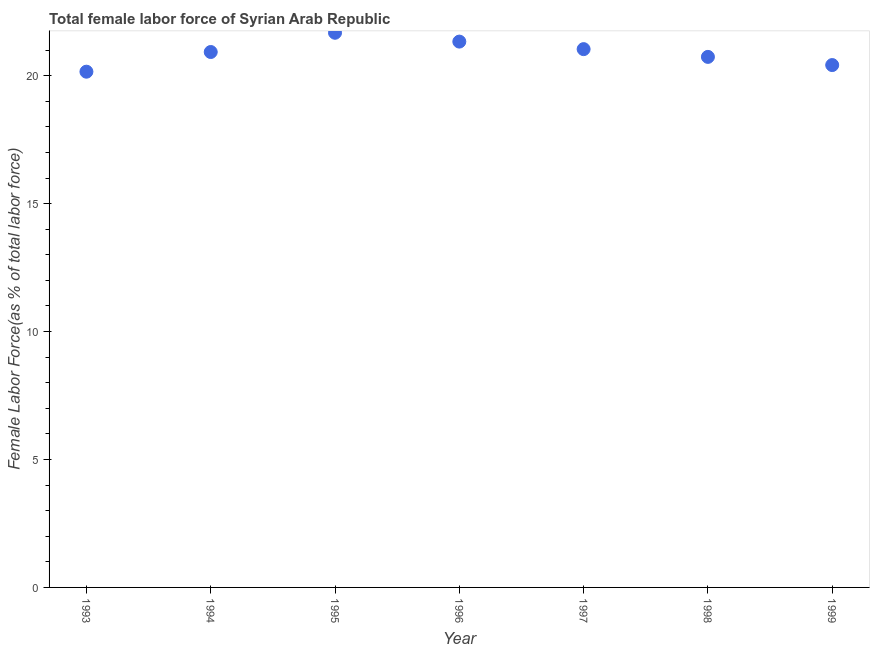What is the total female labor force in 1997?
Make the answer very short. 21.04. Across all years, what is the maximum total female labor force?
Ensure brevity in your answer.  21.68. Across all years, what is the minimum total female labor force?
Your answer should be compact. 20.16. In which year was the total female labor force maximum?
Provide a short and direct response. 1995. In which year was the total female labor force minimum?
Provide a short and direct response. 1993. What is the sum of the total female labor force?
Provide a short and direct response. 146.29. What is the difference between the total female labor force in 1998 and 1999?
Offer a terse response. 0.32. What is the average total female labor force per year?
Provide a succinct answer. 20.9. What is the median total female labor force?
Give a very brief answer. 20.93. What is the ratio of the total female labor force in 1993 to that in 1996?
Provide a short and direct response. 0.94. Is the total female labor force in 1998 less than that in 1999?
Your response must be concise. No. Is the difference between the total female labor force in 1993 and 1994 greater than the difference between any two years?
Provide a succinct answer. No. What is the difference between the highest and the second highest total female labor force?
Ensure brevity in your answer.  0.35. Is the sum of the total female labor force in 1993 and 1995 greater than the maximum total female labor force across all years?
Provide a short and direct response. Yes. What is the difference between the highest and the lowest total female labor force?
Keep it short and to the point. 1.52. In how many years, is the total female labor force greater than the average total female labor force taken over all years?
Your response must be concise. 4. What is the difference between two consecutive major ticks on the Y-axis?
Offer a terse response. 5. Are the values on the major ticks of Y-axis written in scientific E-notation?
Ensure brevity in your answer.  No. Does the graph contain any zero values?
Your response must be concise. No. Does the graph contain grids?
Make the answer very short. No. What is the title of the graph?
Your response must be concise. Total female labor force of Syrian Arab Republic. What is the label or title of the X-axis?
Keep it short and to the point. Year. What is the label or title of the Y-axis?
Offer a very short reply. Female Labor Force(as % of total labor force). What is the Female Labor Force(as % of total labor force) in 1993?
Offer a terse response. 20.16. What is the Female Labor Force(as % of total labor force) in 1994?
Keep it short and to the point. 20.93. What is the Female Labor Force(as % of total labor force) in 1995?
Ensure brevity in your answer.  21.68. What is the Female Labor Force(as % of total labor force) in 1996?
Make the answer very short. 21.33. What is the Female Labor Force(as % of total labor force) in 1997?
Provide a succinct answer. 21.04. What is the Female Labor Force(as % of total labor force) in 1998?
Provide a succinct answer. 20.74. What is the Female Labor Force(as % of total labor force) in 1999?
Your response must be concise. 20.42. What is the difference between the Female Labor Force(as % of total labor force) in 1993 and 1994?
Give a very brief answer. -0.77. What is the difference between the Female Labor Force(as % of total labor force) in 1993 and 1995?
Offer a terse response. -1.52. What is the difference between the Female Labor Force(as % of total labor force) in 1993 and 1996?
Offer a very short reply. -1.18. What is the difference between the Female Labor Force(as % of total labor force) in 1993 and 1997?
Your answer should be compact. -0.88. What is the difference between the Female Labor Force(as % of total labor force) in 1993 and 1998?
Give a very brief answer. -0.58. What is the difference between the Female Labor Force(as % of total labor force) in 1993 and 1999?
Provide a succinct answer. -0.26. What is the difference between the Female Labor Force(as % of total labor force) in 1994 and 1995?
Your answer should be compact. -0.75. What is the difference between the Female Labor Force(as % of total labor force) in 1994 and 1996?
Provide a short and direct response. -0.41. What is the difference between the Female Labor Force(as % of total labor force) in 1994 and 1997?
Your response must be concise. -0.11. What is the difference between the Female Labor Force(as % of total labor force) in 1994 and 1998?
Keep it short and to the point. 0.19. What is the difference between the Female Labor Force(as % of total labor force) in 1994 and 1999?
Your answer should be compact. 0.51. What is the difference between the Female Labor Force(as % of total labor force) in 1995 and 1996?
Offer a terse response. 0.35. What is the difference between the Female Labor Force(as % of total labor force) in 1995 and 1997?
Give a very brief answer. 0.64. What is the difference between the Female Labor Force(as % of total labor force) in 1995 and 1998?
Offer a very short reply. 0.94. What is the difference between the Female Labor Force(as % of total labor force) in 1995 and 1999?
Make the answer very short. 1.26. What is the difference between the Female Labor Force(as % of total labor force) in 1996 and 1997?
Your answer should be compact. 0.29. What is the difference between the Female Labor Force(as % of total labor force) in 1996 and 1998?
Your response must be concise. 0.6. What is the difference between the Female Labor Force(as % of total labor force) in 1996 and 1999?
Provide a short and direct response. 0.92. What is the difference between the Female Labor Force(as % of total labor force) in 1997 and 1998?
Offer a terse response. 0.3. What is the difference between the Female Labor Force(as % of total labor force) in 1997 and 1999?
Offer a very short reply. 0.62. What is the difference between the Female Labor Force(as % of total labor force) in 1998 and 1999?
Offer a very short reply. 0.32. What is the ratio of the Female Labor Force(as % of total labor force) in 1993 to that in 1994?
Ensure brevity in your answer.  0.96. What is the ratio of the Female Labor Force(as % of total labor force) in 1993 to that in 1996?
Your answer should be compact. 0.94. What is the ratio of the Female Labor Force(as % of total labor force) in 1993 to that in 1997?
Your response must be concise. 0.96. What is the ratio of the Female Labor Force(as % of total labor force) in 1993 to that in 1998?
Offer a very short reply. 0.97. What is the ratio of the Female Labor Force(as % of total labor force) in 1993 to that in 1999?
Your answer should be compact. 0.99. What is the ratio of the Female Labor Force(as % of total labor force) in 1994 to that in 1996?
Your answer should be very brief. 0.98. What is the ratio of the Female Labor Force(as % of total labor force) in 1994 to that in 1997?
Offer a very short reply. 0.99. What is the ratio of the Female Labor Force(as % of total labor force) in 1995 to that in 1998?
Keep it short and to the point. 1.04. What is the ratio of the Female Labor Force(as % of total labor force) in 1995 to that in 1999?
Offer a very short reply. 1.06. What is the ratio of the Female Labor Force(as % of total labor force) in 1996 to that in 1999?
Make the answer very short. 1.04. What is the ratio of the Female Labor Force(as % of total labor force) in 1997 to that in 1998?
Ensure brevity in your answer.  1.01. What is the ratio of the Female Labor Force(as % of total labor force) in 1997 to that in 1999?
Give a very brief answer. 1.03. What is the ratio of the Female Labor Force(as % of total labor force) in 1998 to that in 1999?
Give a very brief answer. 1.02. 